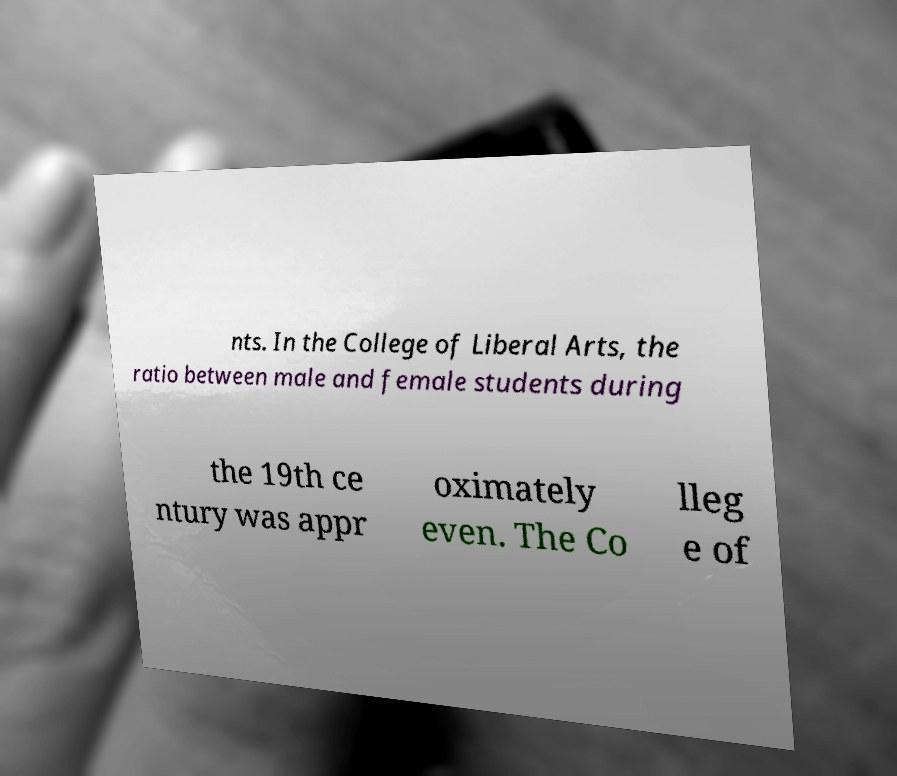Can you accurately transcribe the text from the provided image for me? nts. In the College of Liberal Arts, the ratio between male and female students during the 19th ce ntury was appr oximately even. The Co lleg e of 